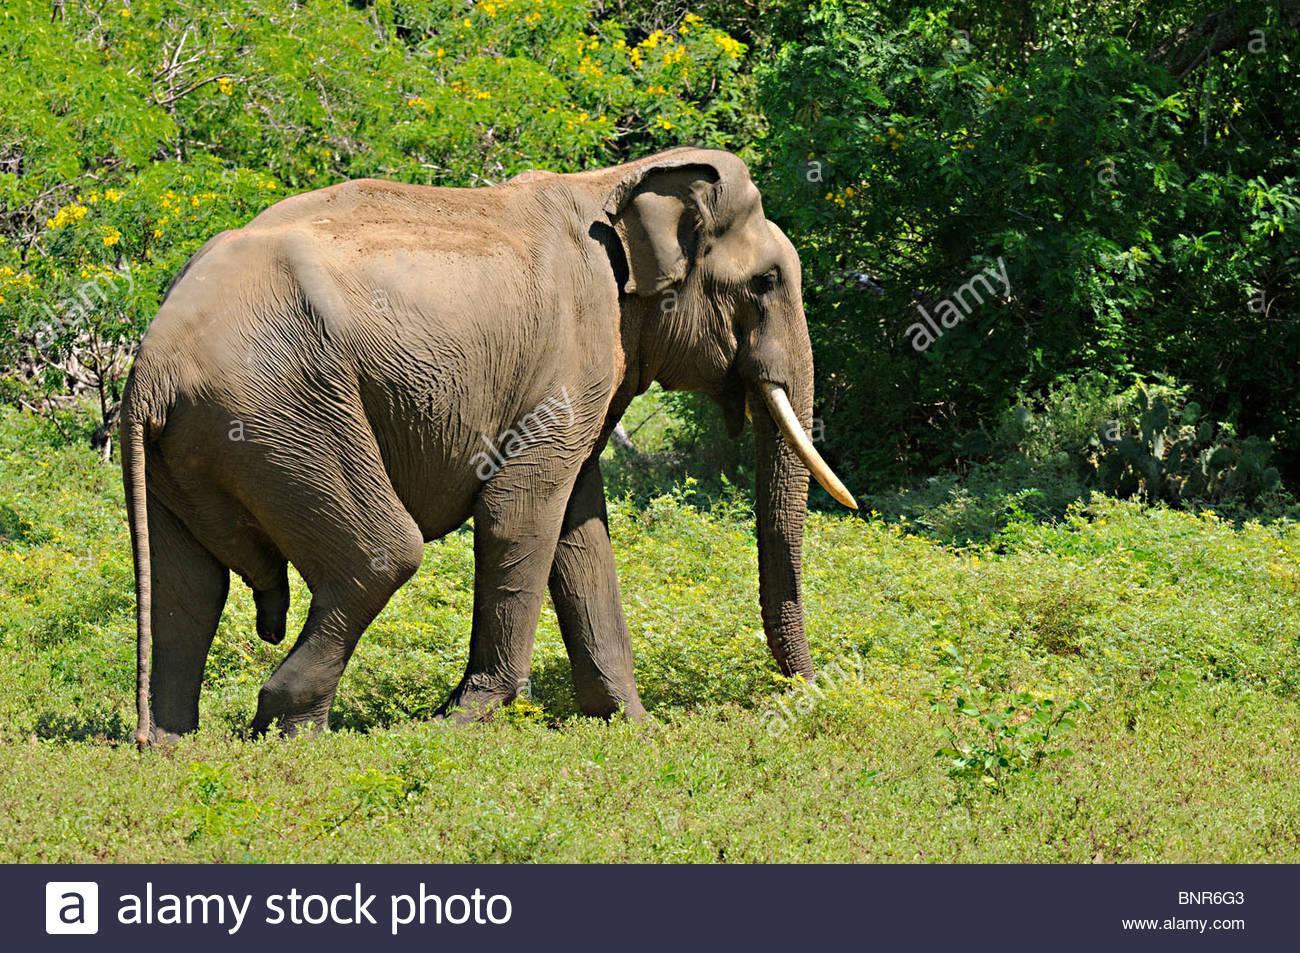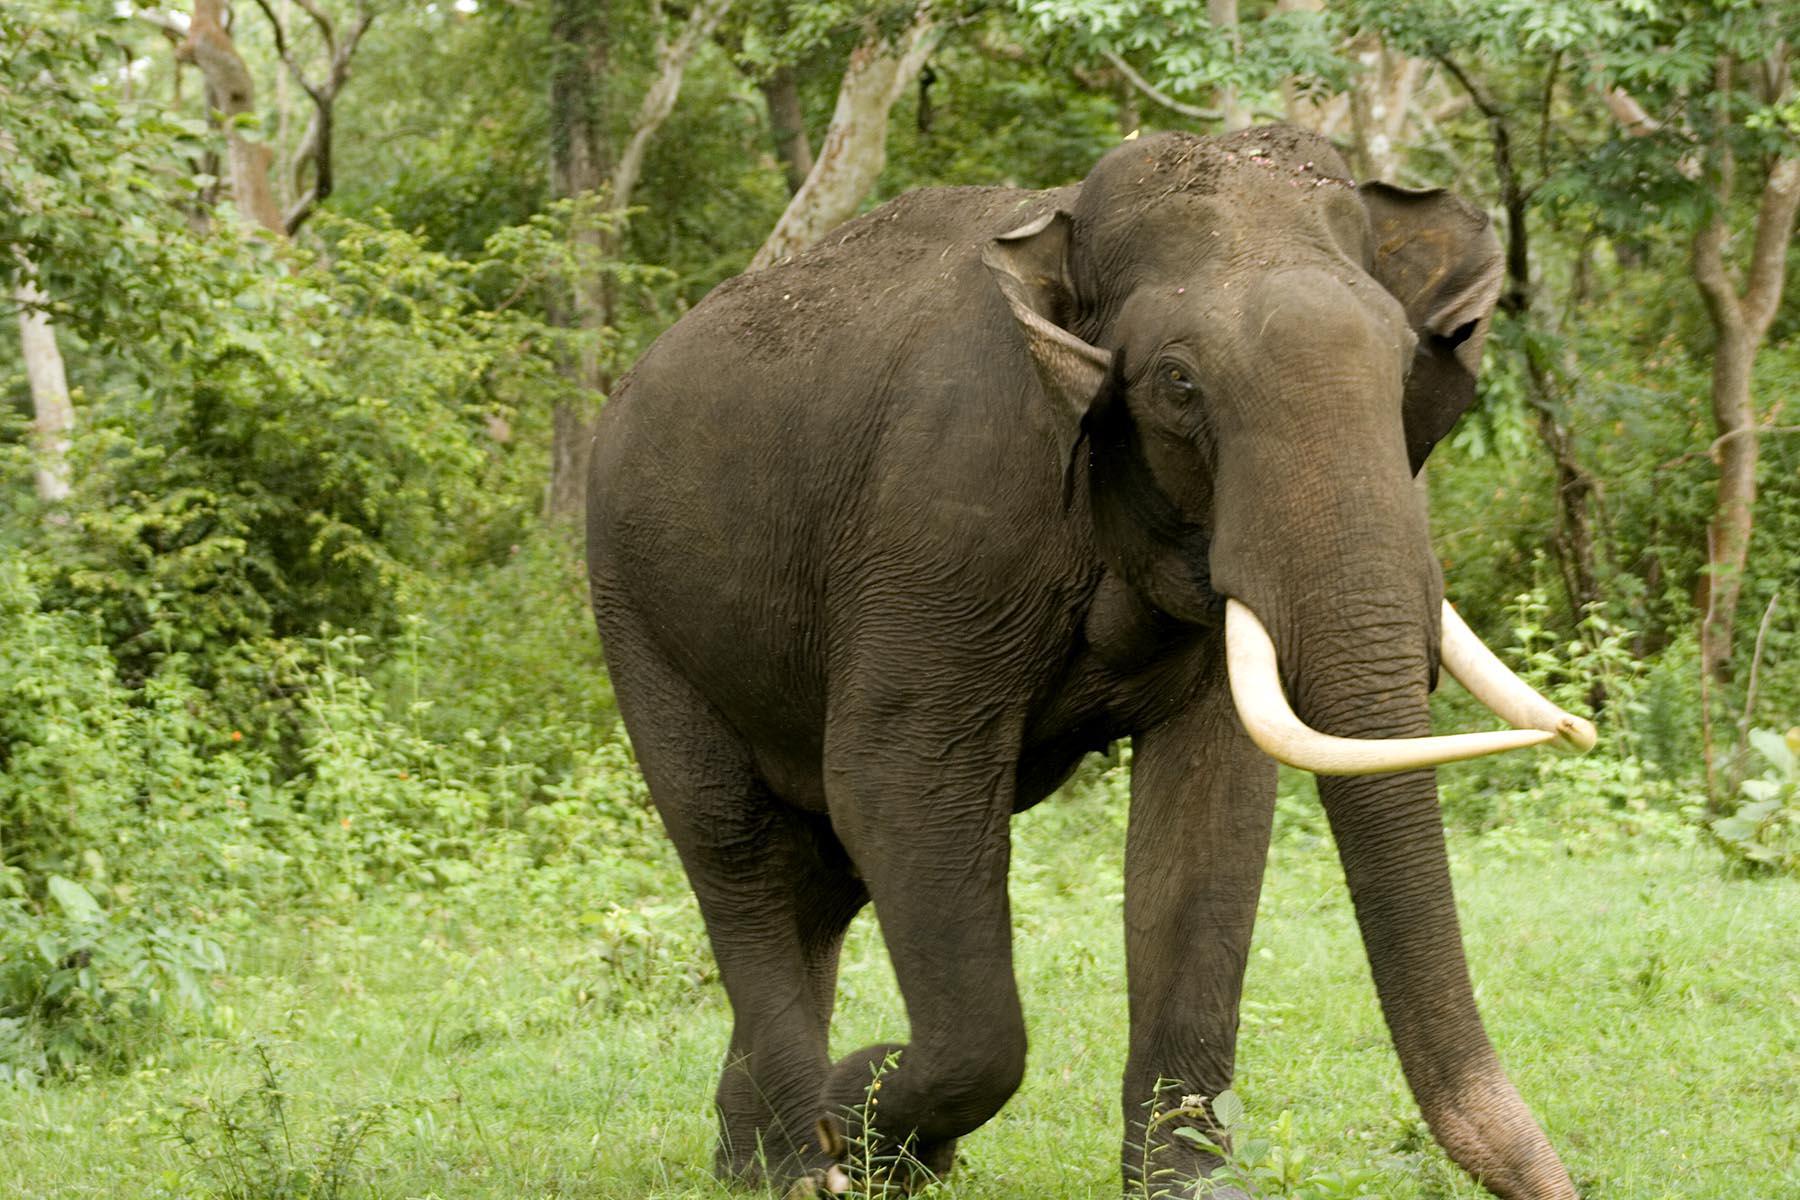The first image is the image on the left, the second image is the image on the right. For the images displayed, is the sentence "At least one image contains one elephant, which has large tusks." factually correct? Answer yes or no. Yes. The first image is the image on the left, the second image is the image on the right. For the images shown, is this caption "There is exactly one animal in the image on the right." true? Answer yes or no. Yes. 